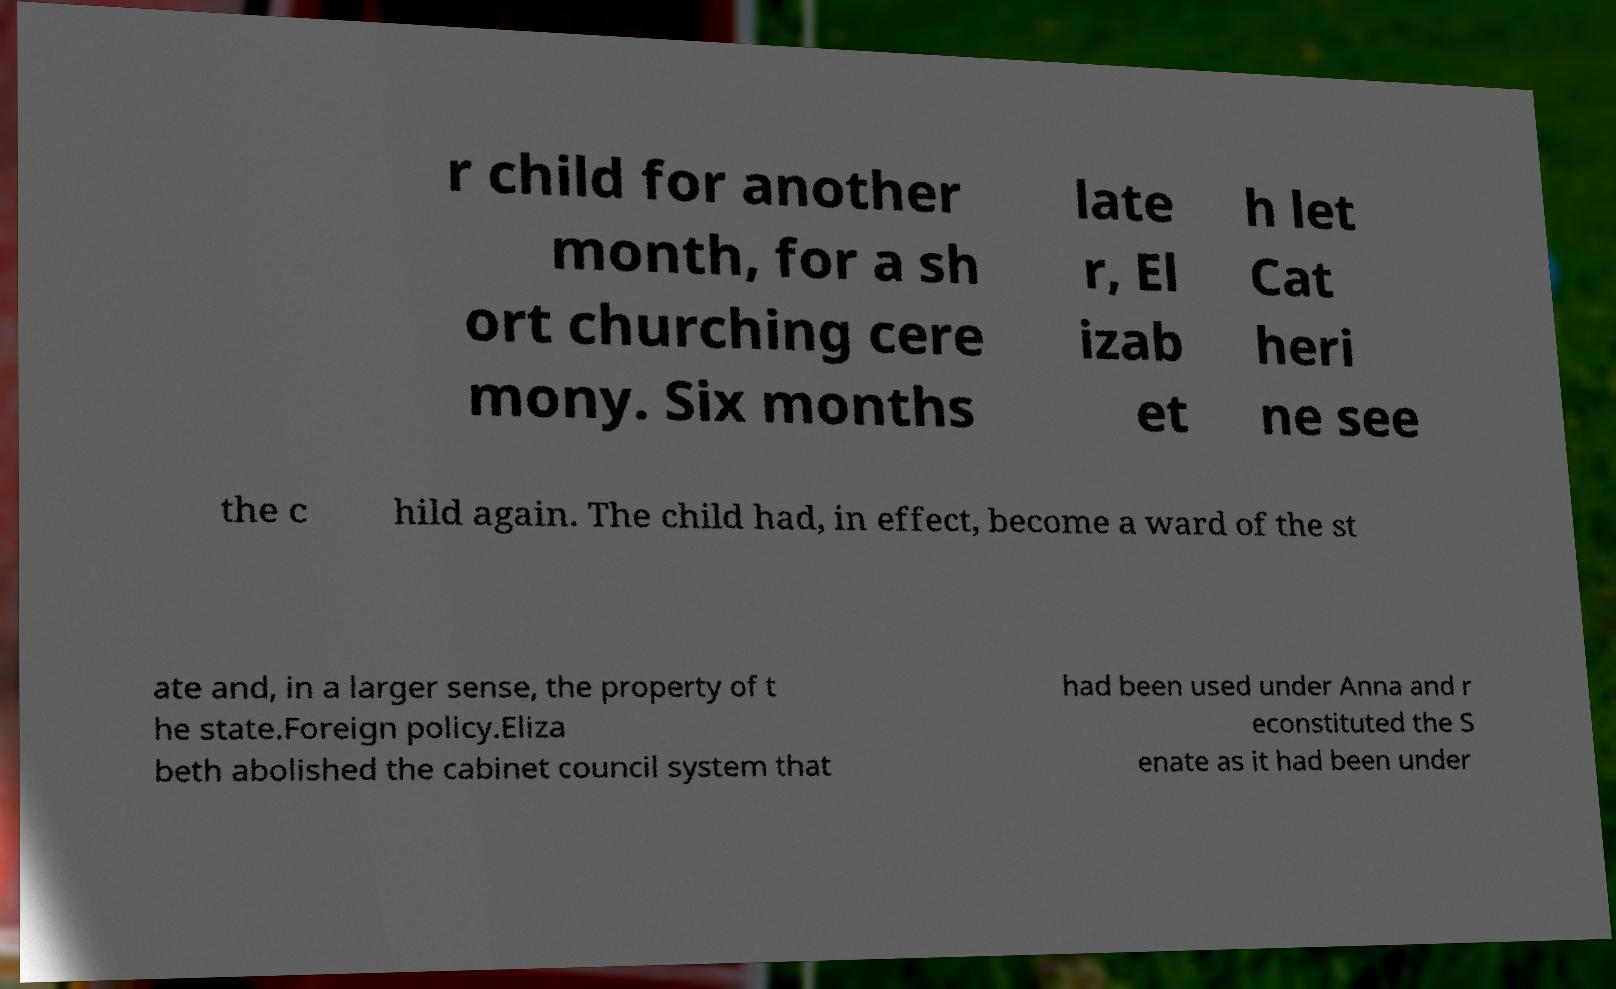Could you extract and type out the text from this image? r child for another month, for a sh ort churching cere mony. Six months late r, El izab et h let Cat heri ne see the c hild again. The child had, in effect, become a ward of the st ate and, in a larger sense, the property of t he state.Foreign policy.Eliza beth abolished the cabinet council system that had been used under Anna and r econstituted the S enate as it had been under 